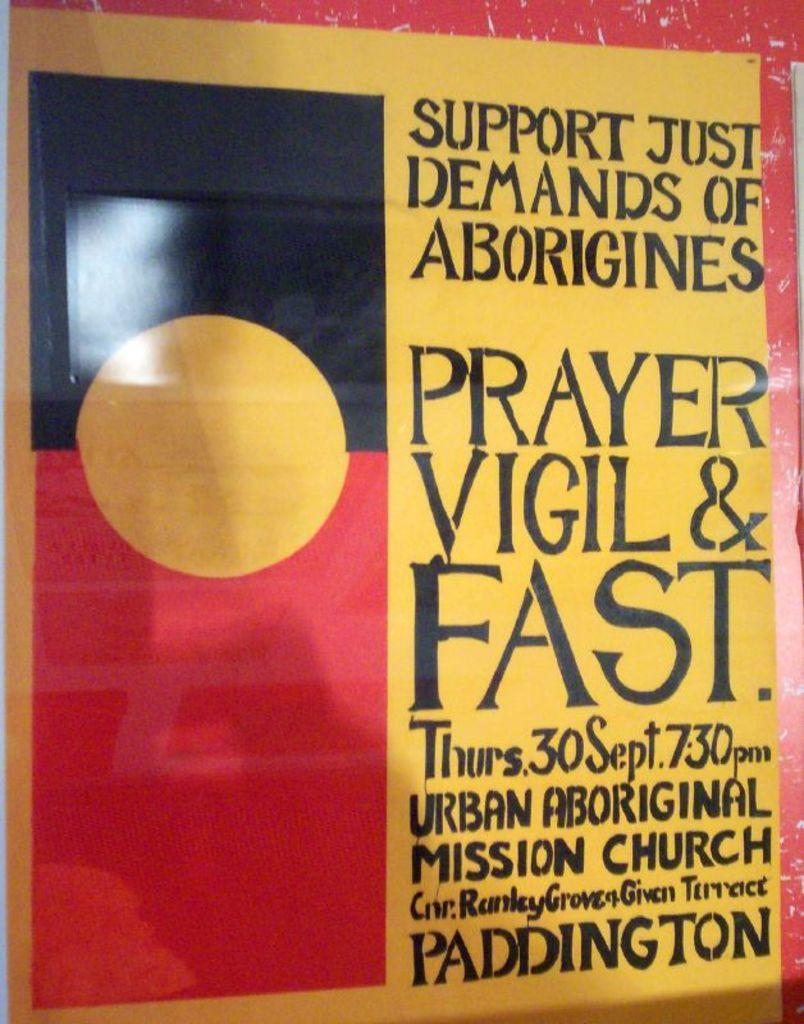<image>
Create a compact narrative representing the image presented. A poster for a prayer vigil and fast on Thursday the 30th of September. 